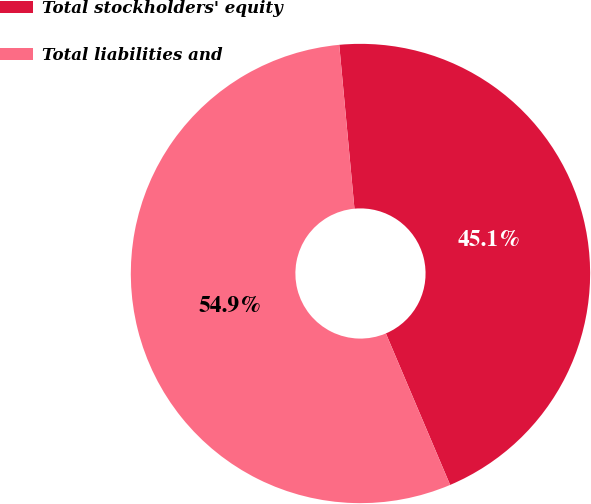<chart> <loc_0><loc_0><loc_500><loc_500><pie_chart><fcel>Total stockholders' equity<fcel>Total liabilities and<nl><fcel>45.09%<fcel>54.91%<nl></chart> 